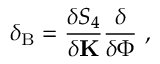<formula> <loc_0><loc_0><loc_500><loc_500>\delta _ { B } = \frac { \delta S _ { 4 } } { \delta { K } } \frac { \delta } { \delta \Phi } \ ,</formula> 